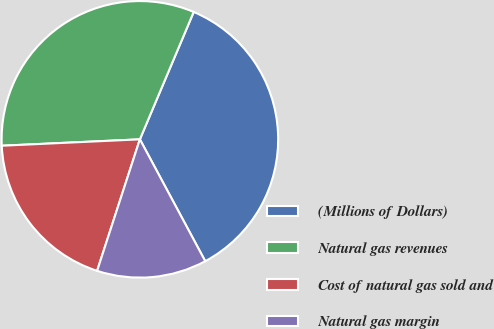Convert chart to OTSL. <chart><loc_0><loc_0><loc_500><loc_500><pie_chart><fcel>(Millions of Dollars)<fcel>Natural gas revenues<fcel>Cost of natural gas sold and<fcel>Natural gas margin<nl><fcel>35.8%<fcel>32.1%<fcel>19.26%<fcel>12.84%<nl></chart> 